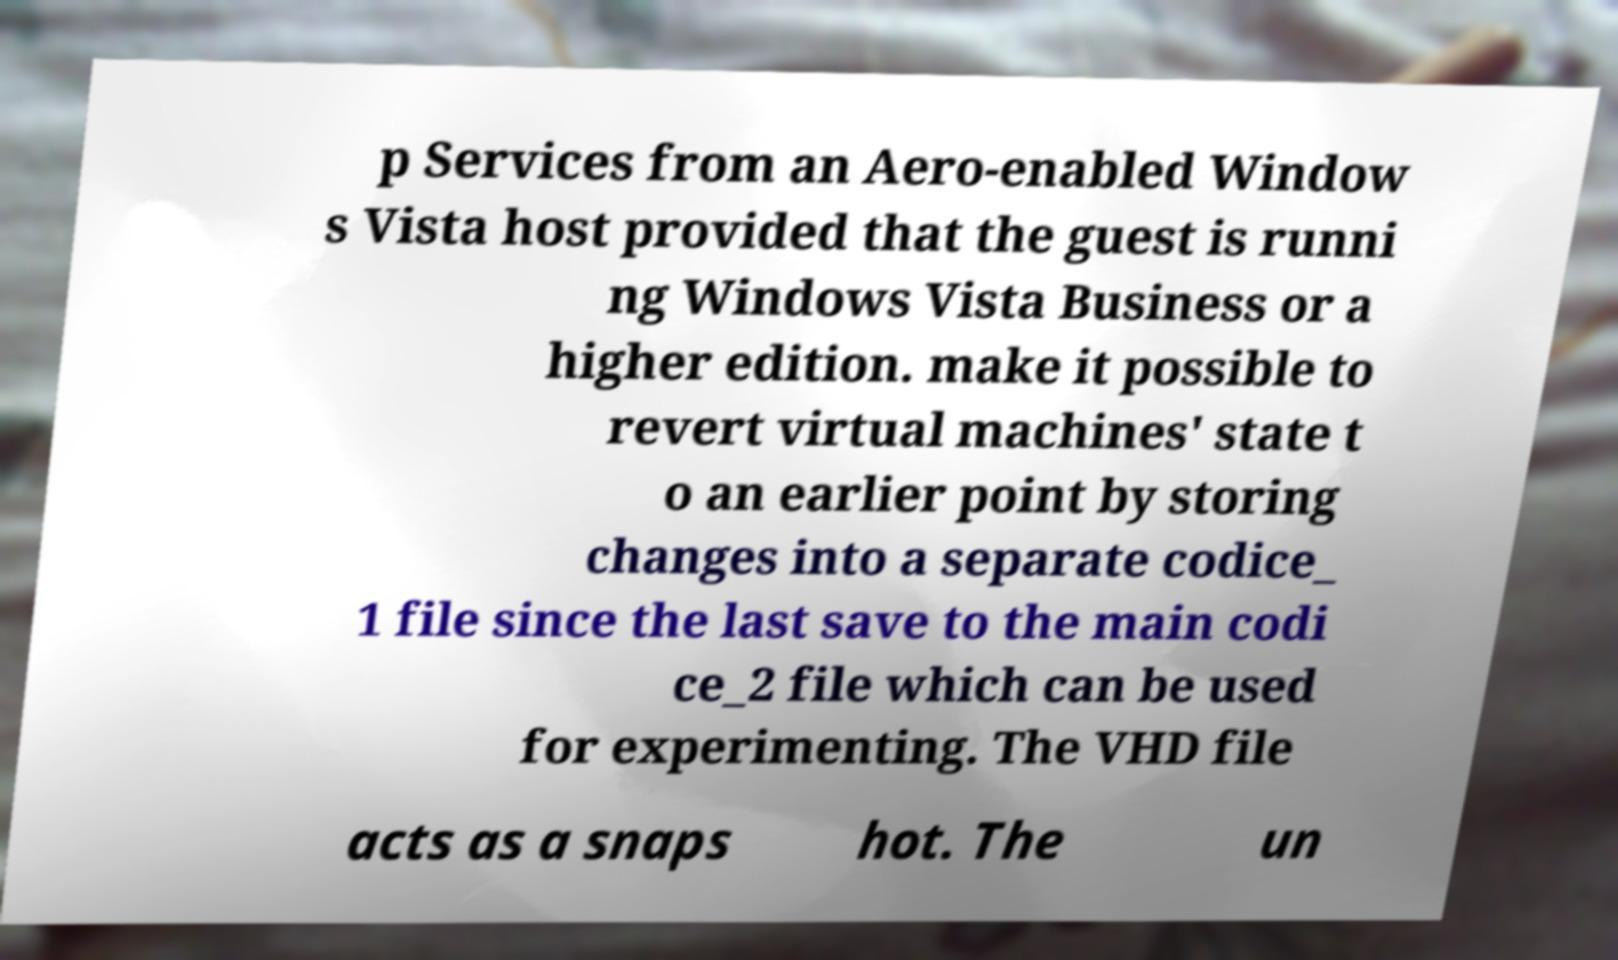Can you accurately transcribe the text from the provided image for me? p Services from an Aero-enabled Window s Vista host provided that the guest is runni ng Windows Vista Business or a higher edition. make it possible to revert virtual machines' state t o an earlier point by storing changes into a separate codice_ 1 file since the last save to the main codi ce_2 file which can be used for experimenting. The VHD file acts as a snaps hot. The un 